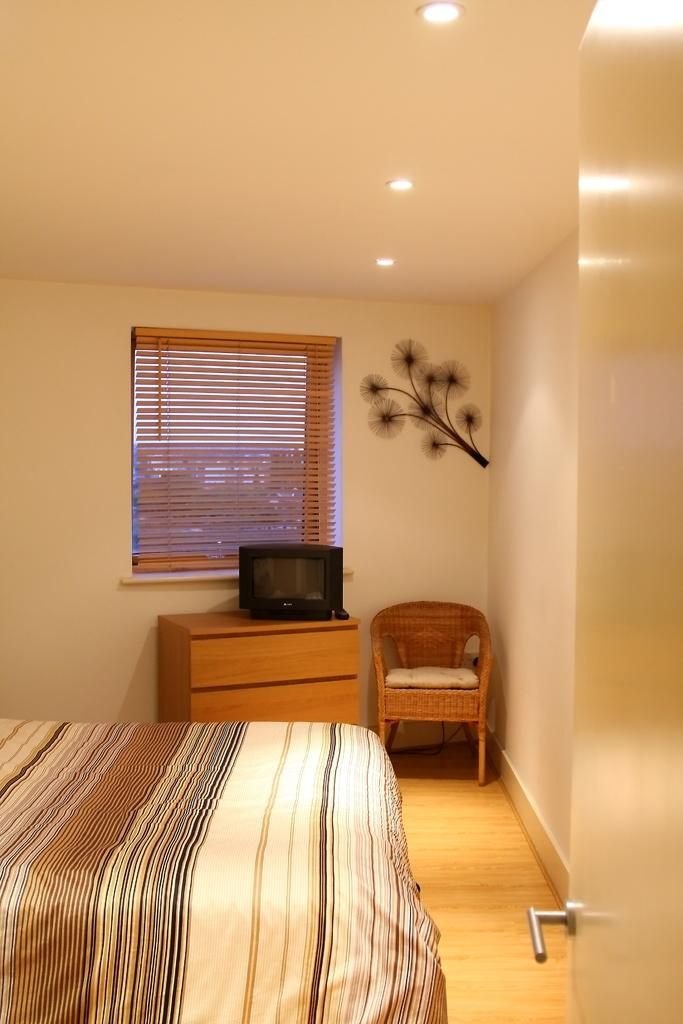What type of furniture is present in the room? There is a bed, a chair, and a cupboard in the room. What is placed on top of the cupboard? There is a television on the cupboard. What can be used to control the amount of light entering the room? There is a window with curtains in the room. How can one enter or exit the room? There is a door in the room. Can you see any flames coming from the bed in the image? There are no flames present in the image, and the bed does not appear to be on fire. What type of trees can be seen through the window in the image? There is no mention of trees in the image, and the window only shows the curtains and the view outside. 